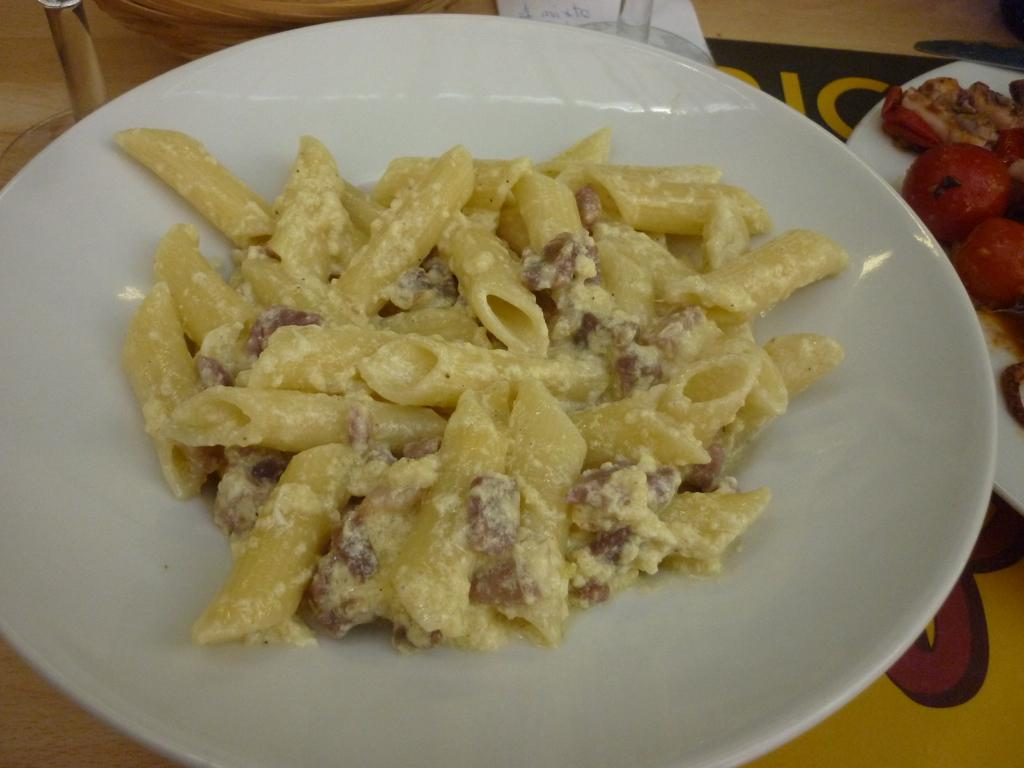What type of food is on the first plate in the image? There is a plate with pasta in the image. What is on the second plate in the image? There is another plate with food stuff in the image. Where is the second plate located in relation to the first plate? The second plate is on the right side of the image. How is the second plate positioned in the image? The second plate is at the top of the image. What is the name of the nail that is holding the plate in the image? There is no nail present in the image; the plates are resting on a surface. 